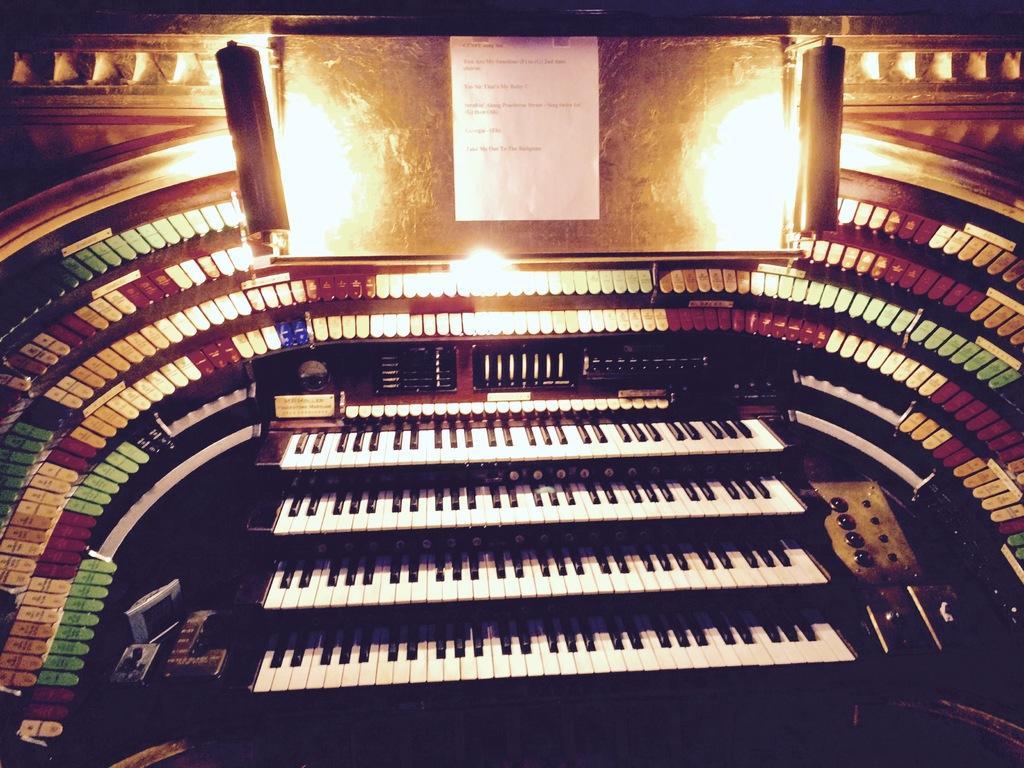Could you give a brief overview of what you see in this image? In this image I can see few plants, in front I can see a paper attached to the board. 